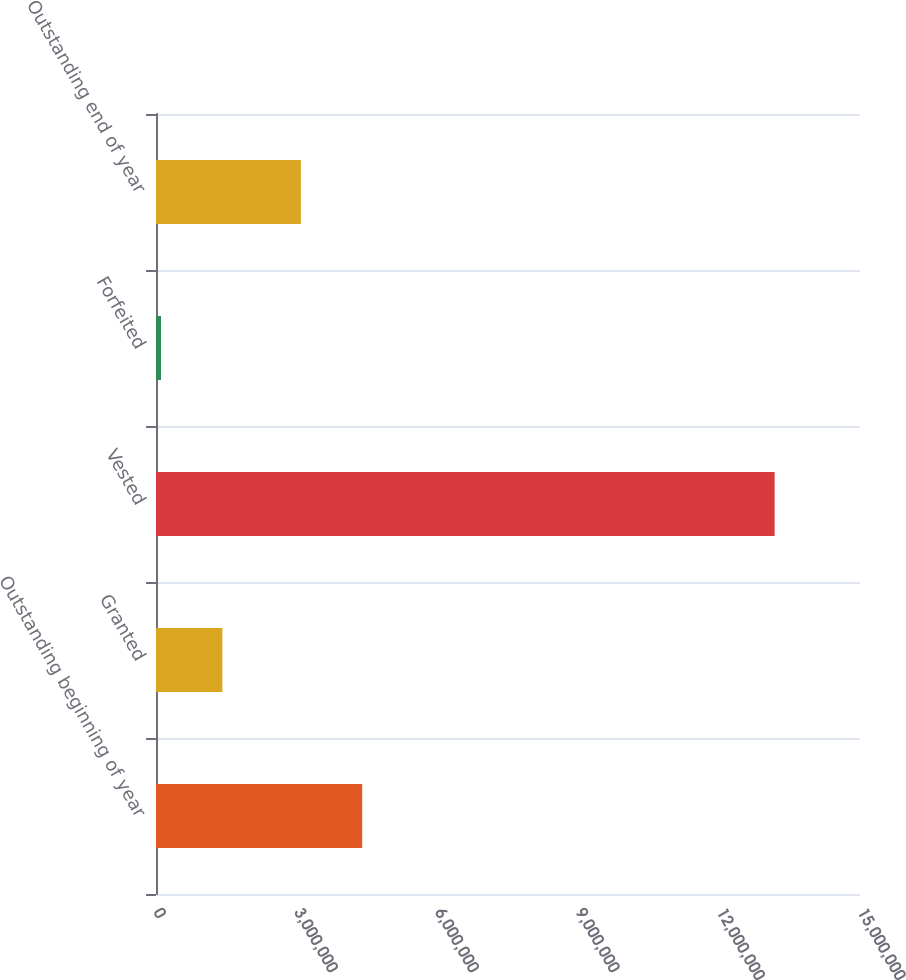Convert chart. <chart><loc_0><loc_0><loc_500><loc_500><bar_chart><fcel>Outstanding beginning of year<fcel>Granted<fcel>Vested<fcel>Forfeited<fcel>Outstanding end of year<nl><fcel>4.39377e+06<fcel>1.4146e+06<fcel>1.31814e+07<fcel>107175<fcel>3.08635e+06<nl></chart> 